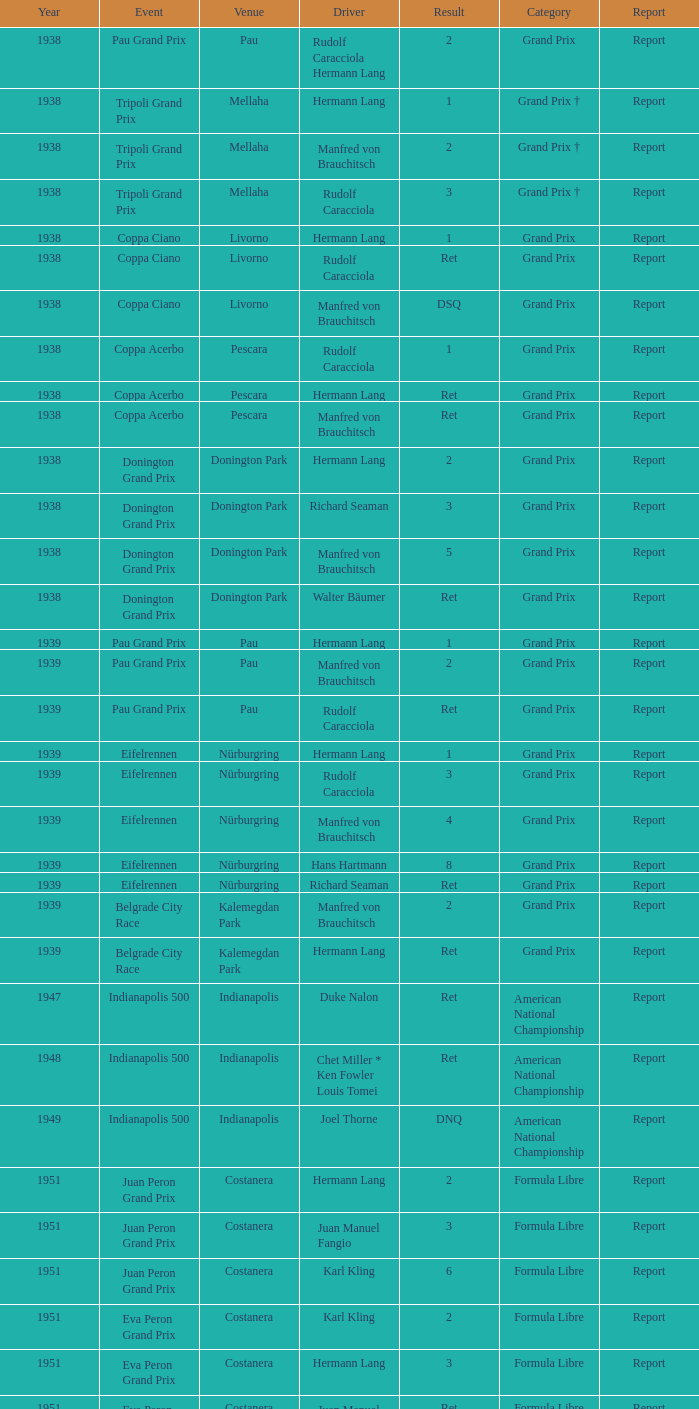When did hans hartmann operate a vehicle? 1.0. 